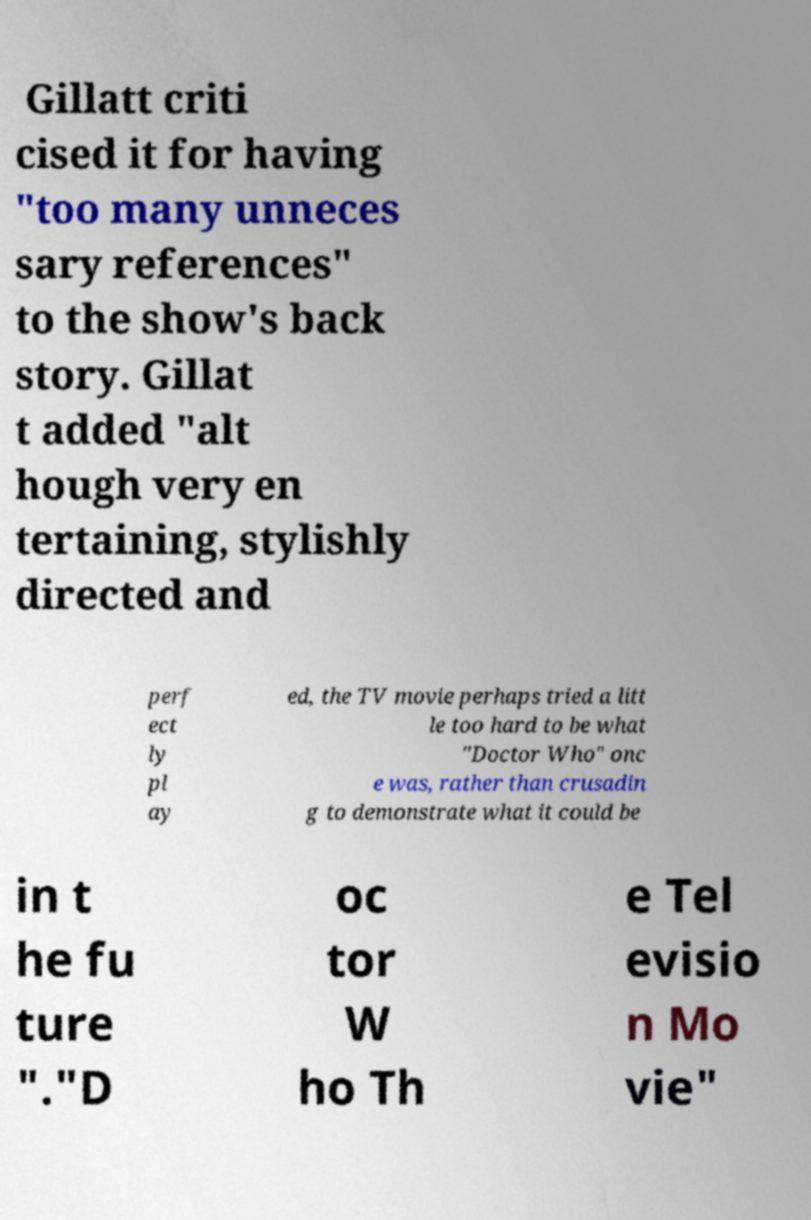Please read and relay the text visible in this image. What does it say? Gillatt criti cised it for having "too many unneces sary references" to the show's back story. Gillat t added "alt hough very en tertaining, stylishly directed and perf ect ly pl ay ed, the TV movie perhaps tried a litt le too hard to be what "Doctor Who" onc e was, rather than crusadin g to demonstrate what it could be in t he fu ture "."D oc tor W ho Th e Tel evisio n Mo vie" 